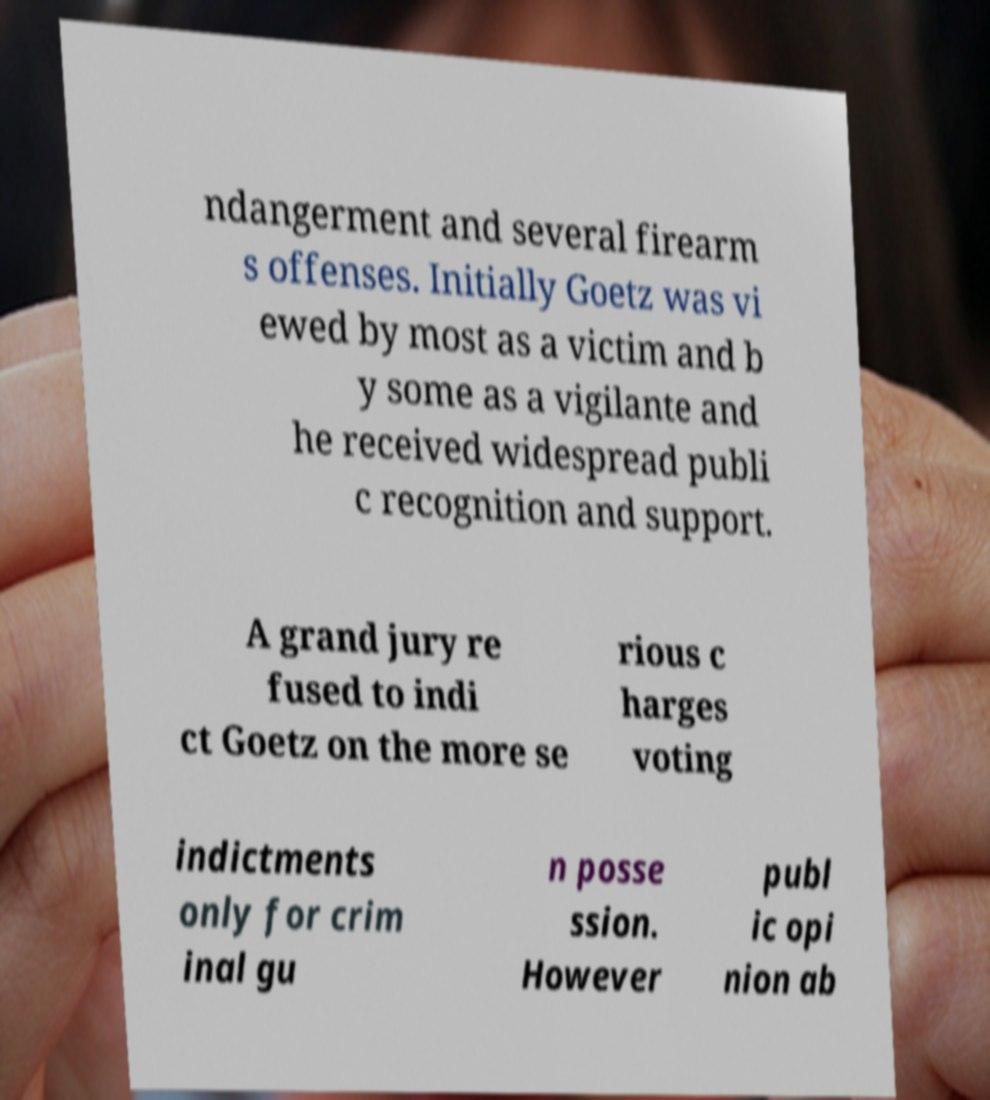There's text embedded in this image that I need extracted. Can you transcribe it verbatim? ndangerment and several firearm s offenses. Initially Goetz was vi ewed by most as a victim and b y some as a vigilante and he received widespread publi c recognition and support. A grand jury re fused to indi ct Goetz on the more se rious c harges voting indictments only for crim inal gu n posse ssion. However publ ic opi nion ab 